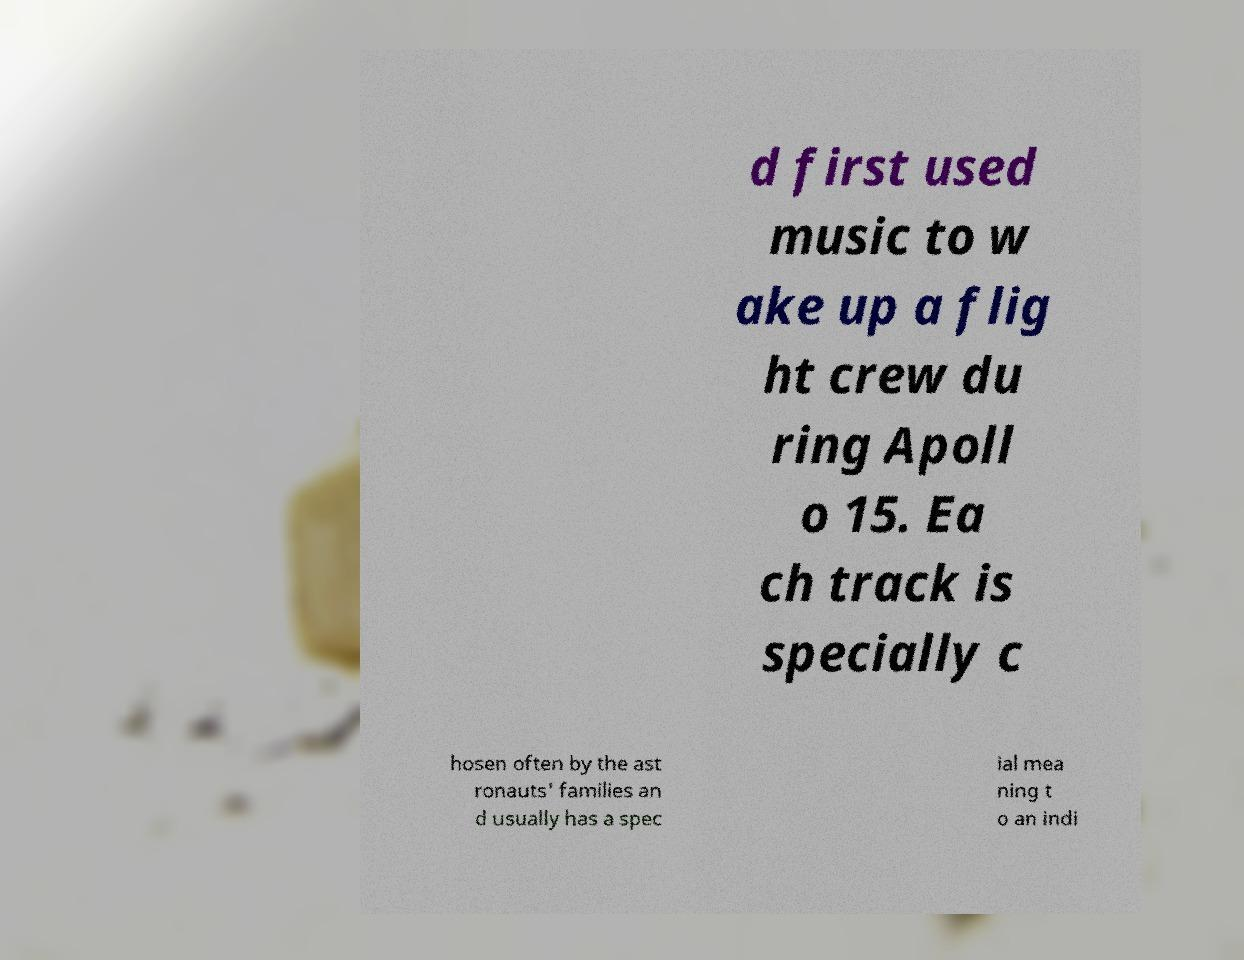Could you assist in decoding the text presented in this image and type it out clearly? d first used music to w ake up a flig ht crew du ring Apoll o 15. Ea ch track is specially c hosen often by the ast ronauts' families an d usually has a spec ial mea ning t o an indi 